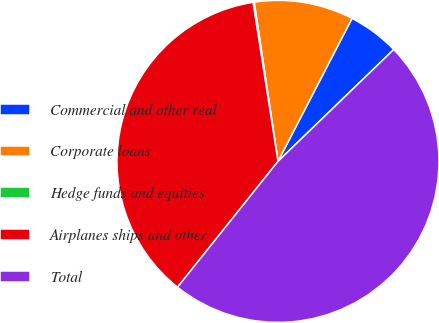<chart> <loc_0><loc_0><loc_500><loc_500><pie_chart><fcel>Commercial and other real<fcel>Corporate loans<fcel>Hedge funds and equities<fcel>Airplanes ships and other<fcel>Total<nl><fcel>5.17%<fcel>9.96%<fcel>0.12%<fcel>36.8%<fcel>47.95%<nl></chart> 